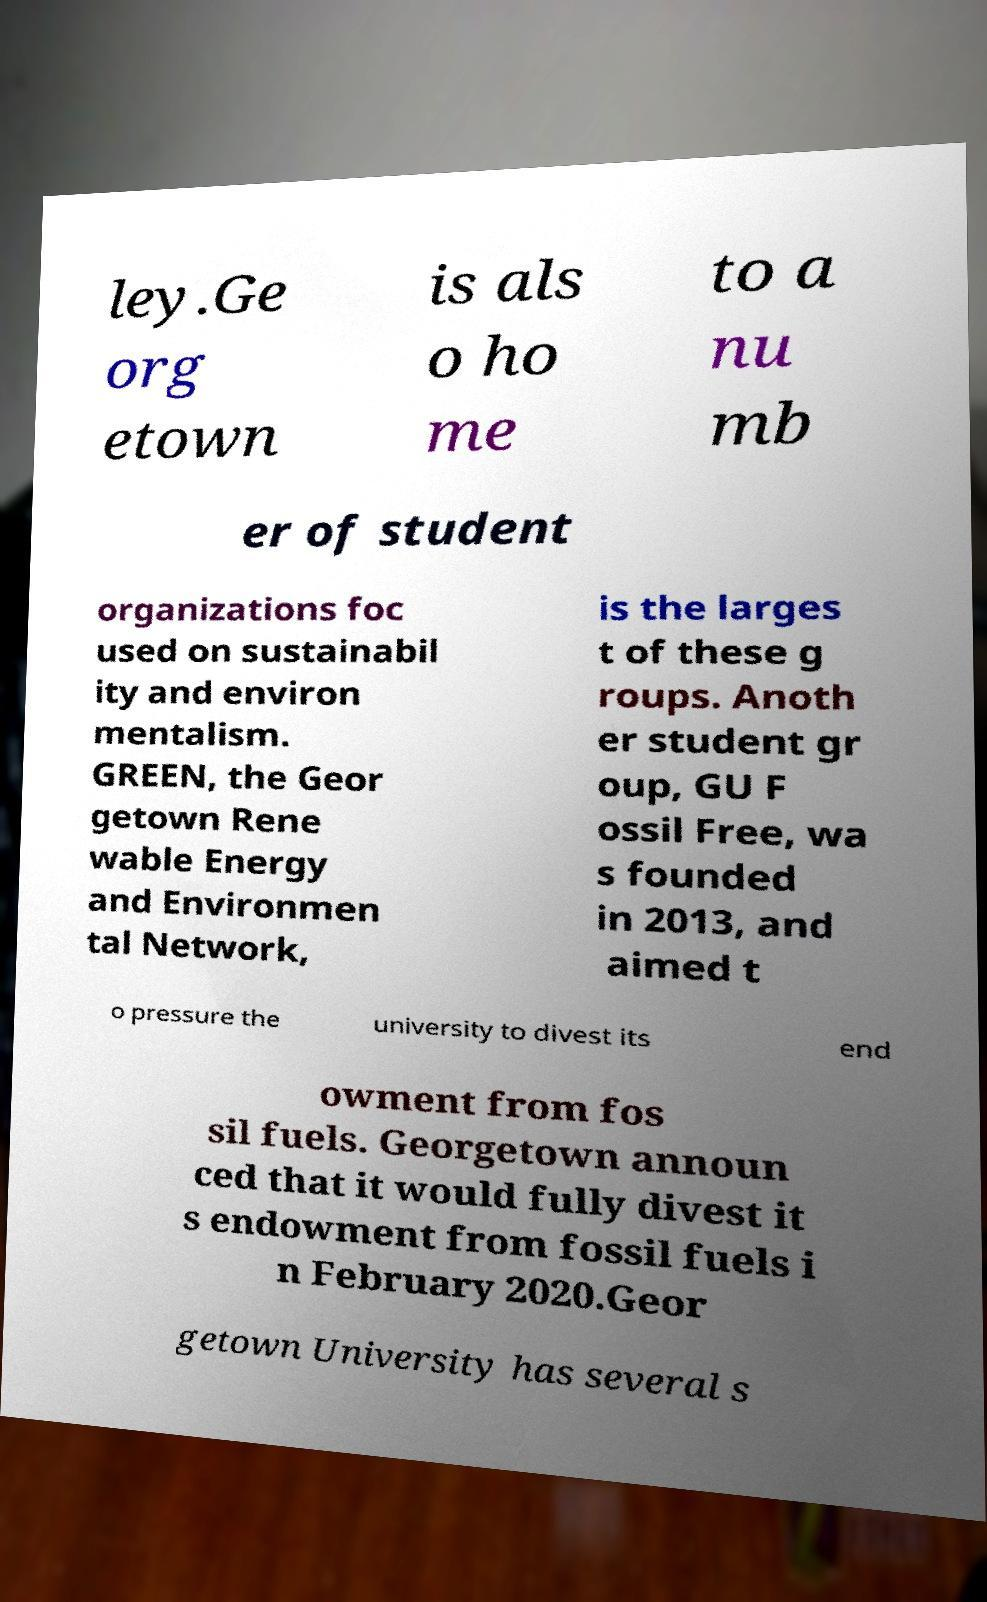For documentation purposes, I need the text within this image transcribed. Could you provide that? ley.Ge org etown is als o ho me to a nu mb er of student organizations foc used on sustainabil ity and environ mentalism. GREEN, the Geor getown Rene wable Energy and Environmen tal Network, is the larges t of these g roups. Anoth er student gr oup, GU F ossil Free, wa s founded in 2013, and aimed t o pressure the university to divest its end owment from fos sil fuels. Georgetown announ ced that it would fully divest it s endowment from fossil fuels i n February 2020.Geor getown University has several s 